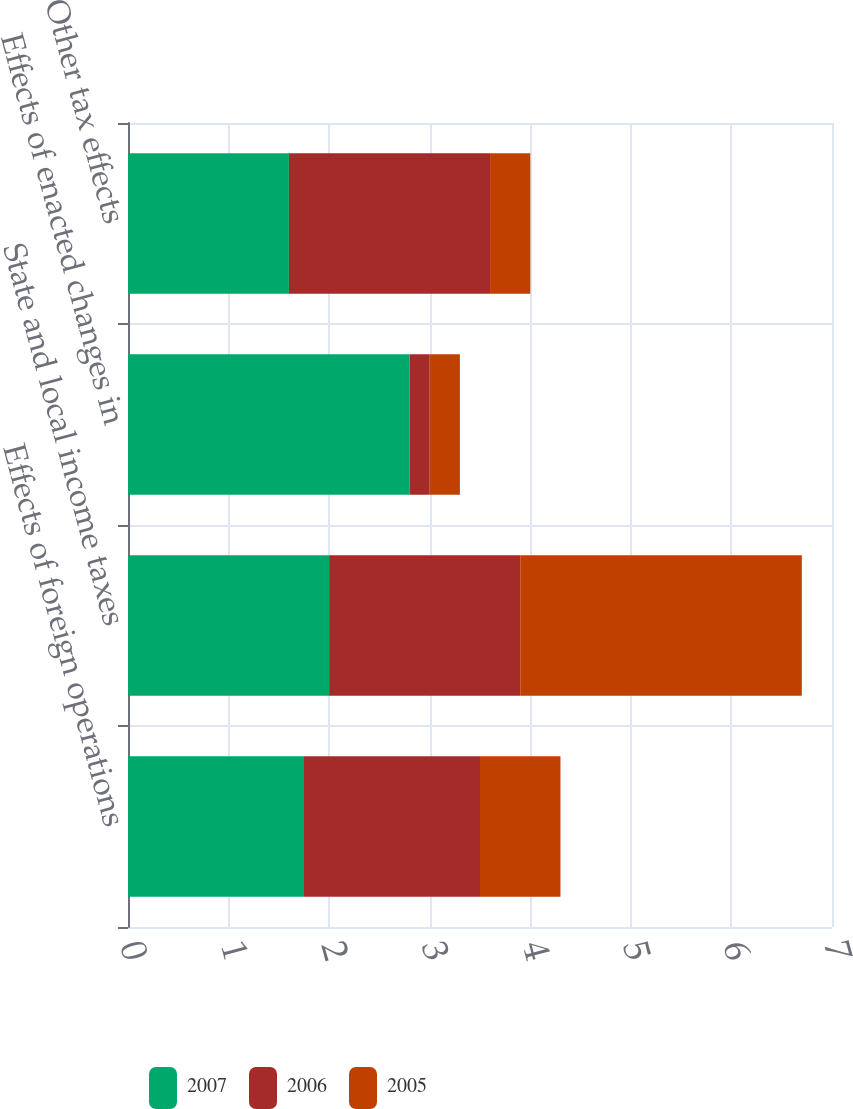Convert chart. <chart><loc_0><loc_0><loc_500><loc_500><stacked_bar_chart><ecel><fcel>Effects of foreign operations<fcel>State and local income taxes<fcel>Effects of enacted changes in<fcel>Other tax effects<nl><fcel>2007<fcel>1.75<fcel>2<fcel>2.8<fcel>1.6<nl><fcel>2006<fcel>1.75<fcel>1.9<fcel>0.2<fcel>2<nl><fcel>2005<fcel>0.8<fcel>2.8<fcel>0.3<fcel>0.4<nl></chart> 